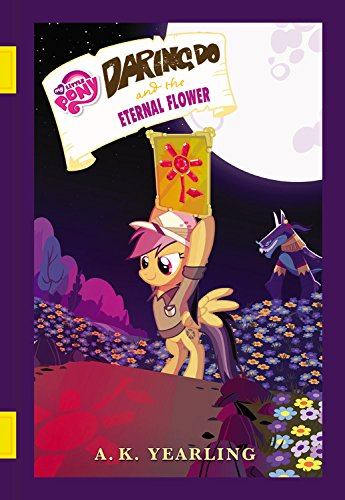Who wrote this book?
Answer the question using a single word or phrase. G. M. Berrow What is the title of this book? My Little Pony: Daring Do and the Eternal Flower What type of book is this? Children's Books Is this a kids book? Yes 